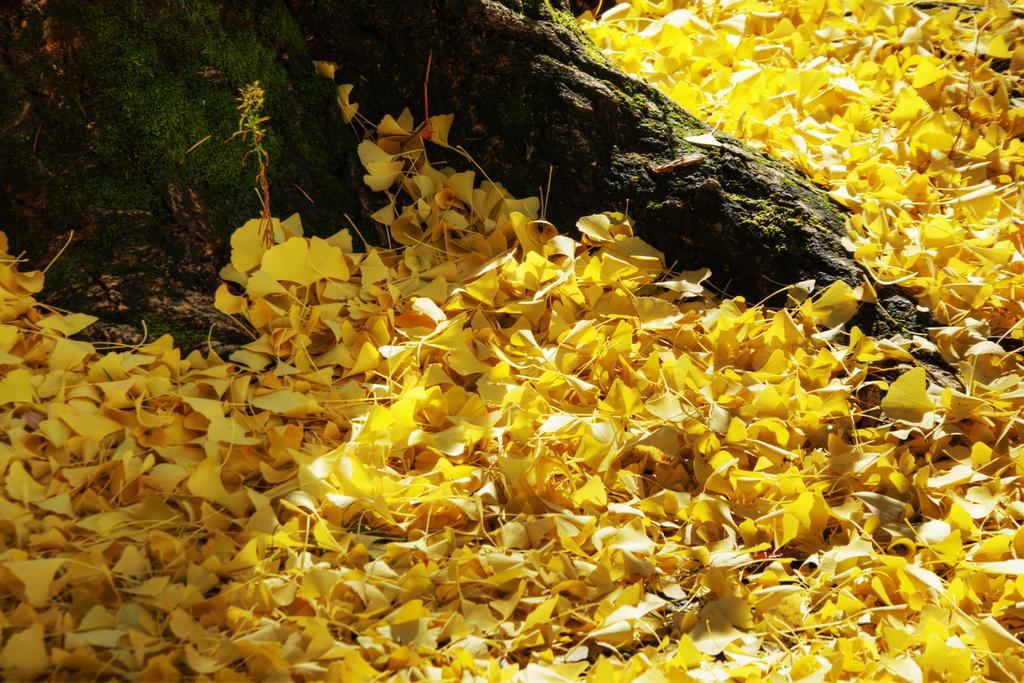Can you describe this image briefly? There are yellow flower petals on the ground and there is a tree trunk at the left. 